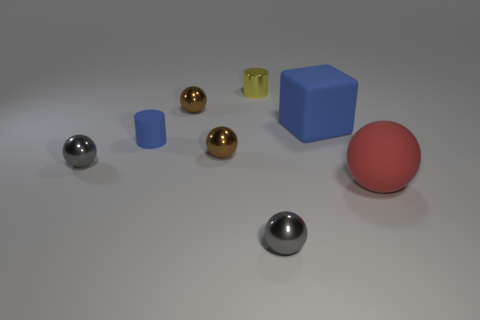Subtract 2 balls. How many balls are left? 3 Subtract all large red rubber balls. How many balls are left? 4 Subtract all green balls. Subtract all brown cubes. How many balls are left? 5 Add 1 small spheres. How many objects exist? 9 Subtract all cylinders. How many objects are left? 6 Subtract all tiny metallic cylinders. Subtract all cyan metal things. How many objects are left? 7 Add 4 tiny brown metal things. How many tiny brown metal things are left? 6 Add 6 large yellow rubber objects. How many large yellow rubber objects exist? 6 Subtract 0 yellow blocks. How many objects are left? 8 